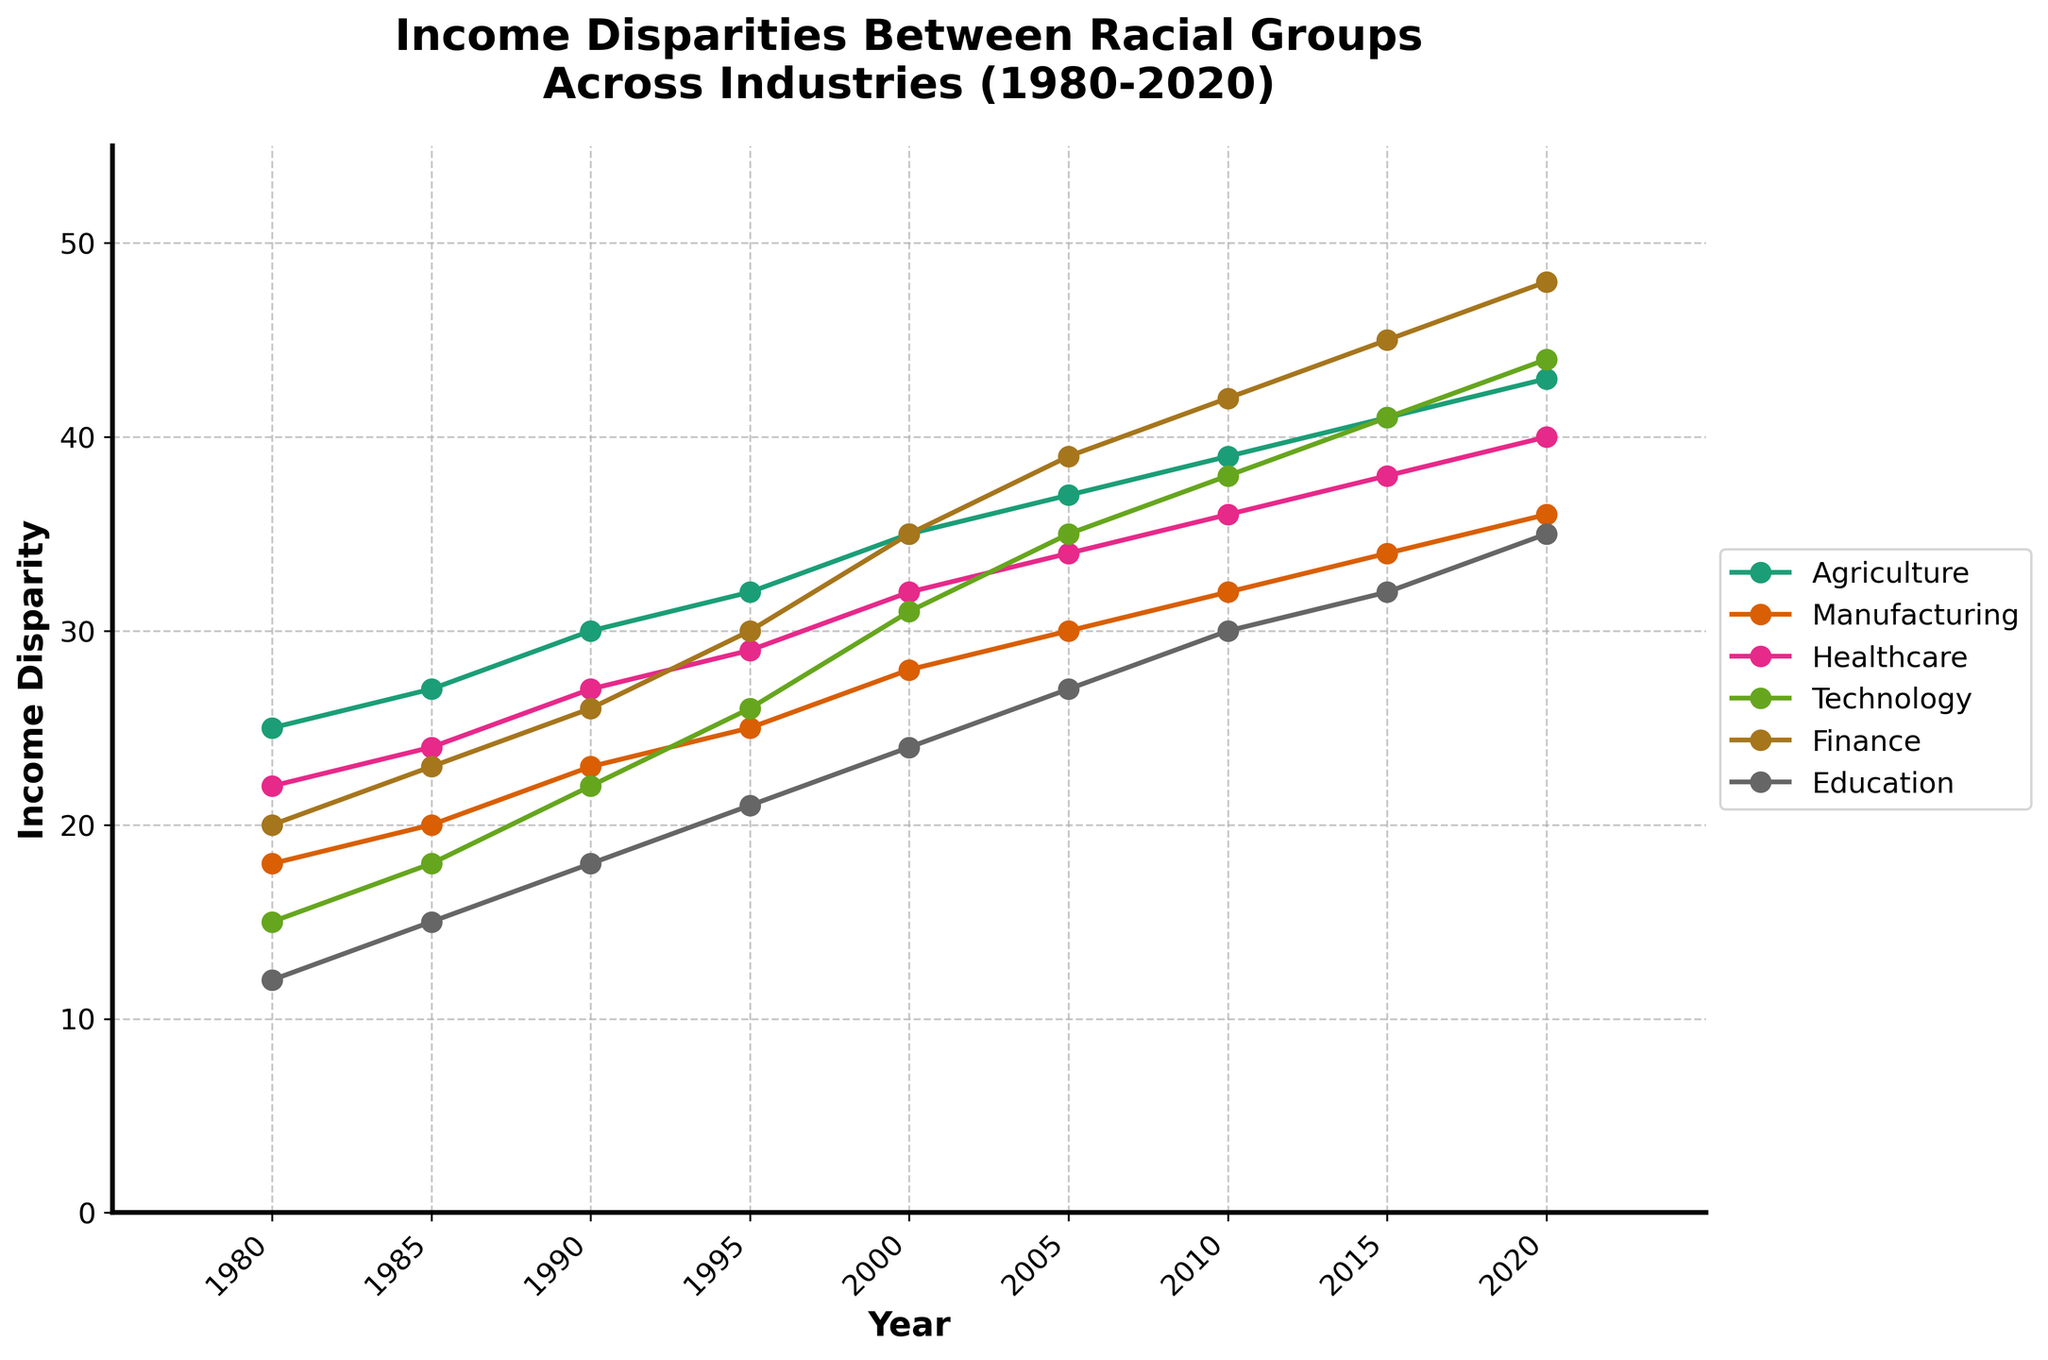What year did the income disparity in the Technology sector exceed 30? By looking at the Technology data line, we see that it exceeded 30 between 1995 and 2000. Therefore, it first exceeded 30 in the year 2000.
Answer: 2000 Which sector showed the most significant increase in income disparity from 1980 to 2020? Calculate the difference for each sector from 1980 to 2020: Agriculture (43-25=18), Manufacturing (36-18=18), Healthcare (40-22=18), Technology (44-15=29), Finance (48-20=28), and Education (35-12=23). The most significant increase is in the Technology sector with a 29-point increase.
Answer: Technology In what year did the Finance sector's income disparity surpass that of Agriculture? By observing the lines for both sectors, Finance's disparity surpassed Agriculture's between 1995 and 2000. The first full surpass is in 2005.
Answer: 2005 Which sector had the smallest income disparity in 1980? Looking at the 1980 data points, Education has the smallest value at 12.
Answer: Education What is the average income disparity in the Healthcare sector from 1980 to 2020? Sum the annual disparities in Healthcare from 1980 to 2020 and then divide by the number of years: (22 + 24 + 27 + 29 + 32 + 34 + 36 + 38 + 40) / 9. The result is 31.
Answer: 31 Which two sectors showed the same income disparity in any given year? By examining the trends, in 2010 both Agriculture and Technology showed an income disparity of 39.
Answer: Agriculture and Technology (2010) Between 1985 and 1995, which sector had the highest average increase in income disparity per year? Calculate the average increase per year for each sector: Agriculture (5/10=0.5), Manufacturing (5/10=0.5), Healthcare (5/10=0.5), Technology (8/10=0.8), Finance (7/10=0.7), Education (6/10=0.6). Technology has the highest average increase of 0.8 per year.
Answer: Technology During which decade did the Manufacturing sector see its steepest increase in income disparity? By examining the Manufacturing line, the steepest rise occurs between 1980 to 1990. The rise is 23-18=5 over 10 years, steepest compared to other decades.
Answer: 1980-1990 Which sectors had an income disparity of 30 or more in the year 2005? Observing the lines at the 2005 mark, Agriculture (37), Manufacturing (30), Healthcare (34), Technology (35), and Finance (39). These all have disparities of 30 or more.
Answer: Agriculture, Manufacturing, Healthcare, Technology, Finance By how much did the income disparity in Finance increase from 1980 to 2000? Subtract the 1980 value from the 2000 value for Finance: 35 - 20 = 15.
Answer: 15 